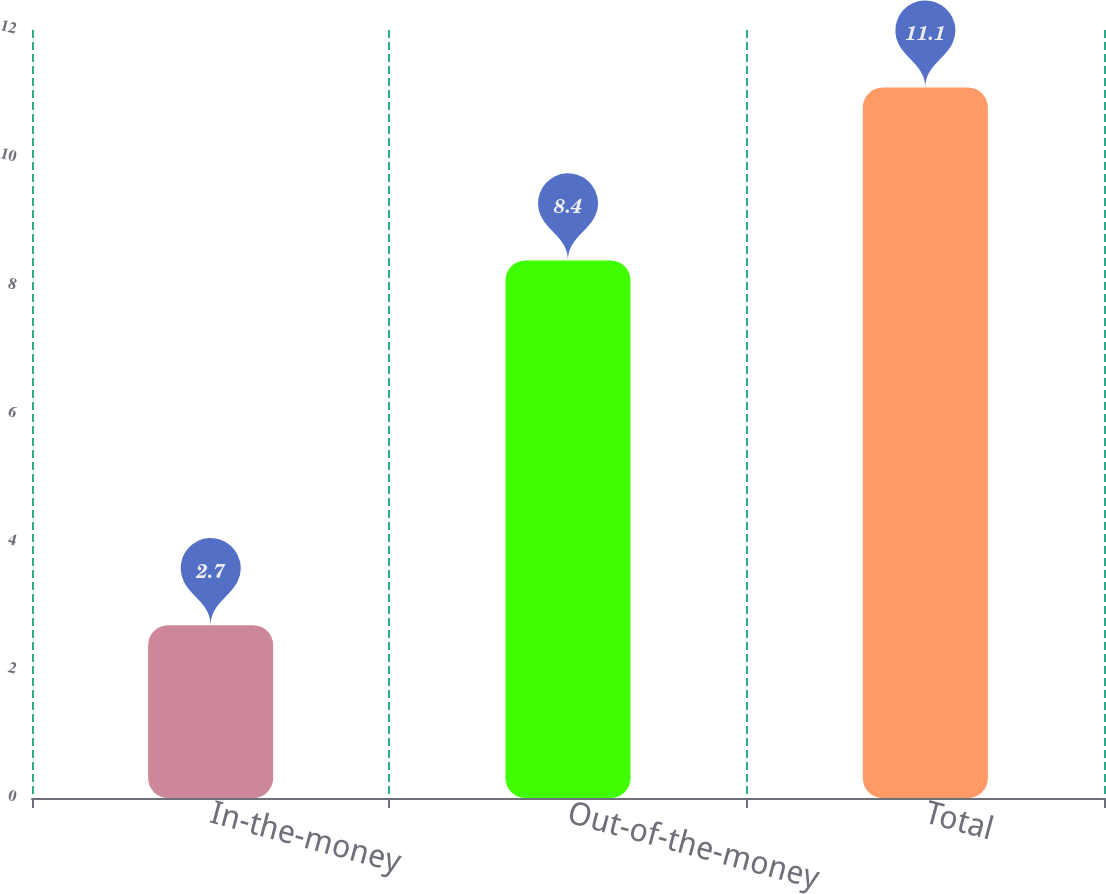Convert chart to OTSL. <chart><loc_0><loc_0><loc_500><loc_500><bar_chart><fcel>In-the-money<fcel>Out-of-the-money<fcel>Total<nl><fcel>2.7<fcel>8.4<fcel>11.1<nl></chart> 